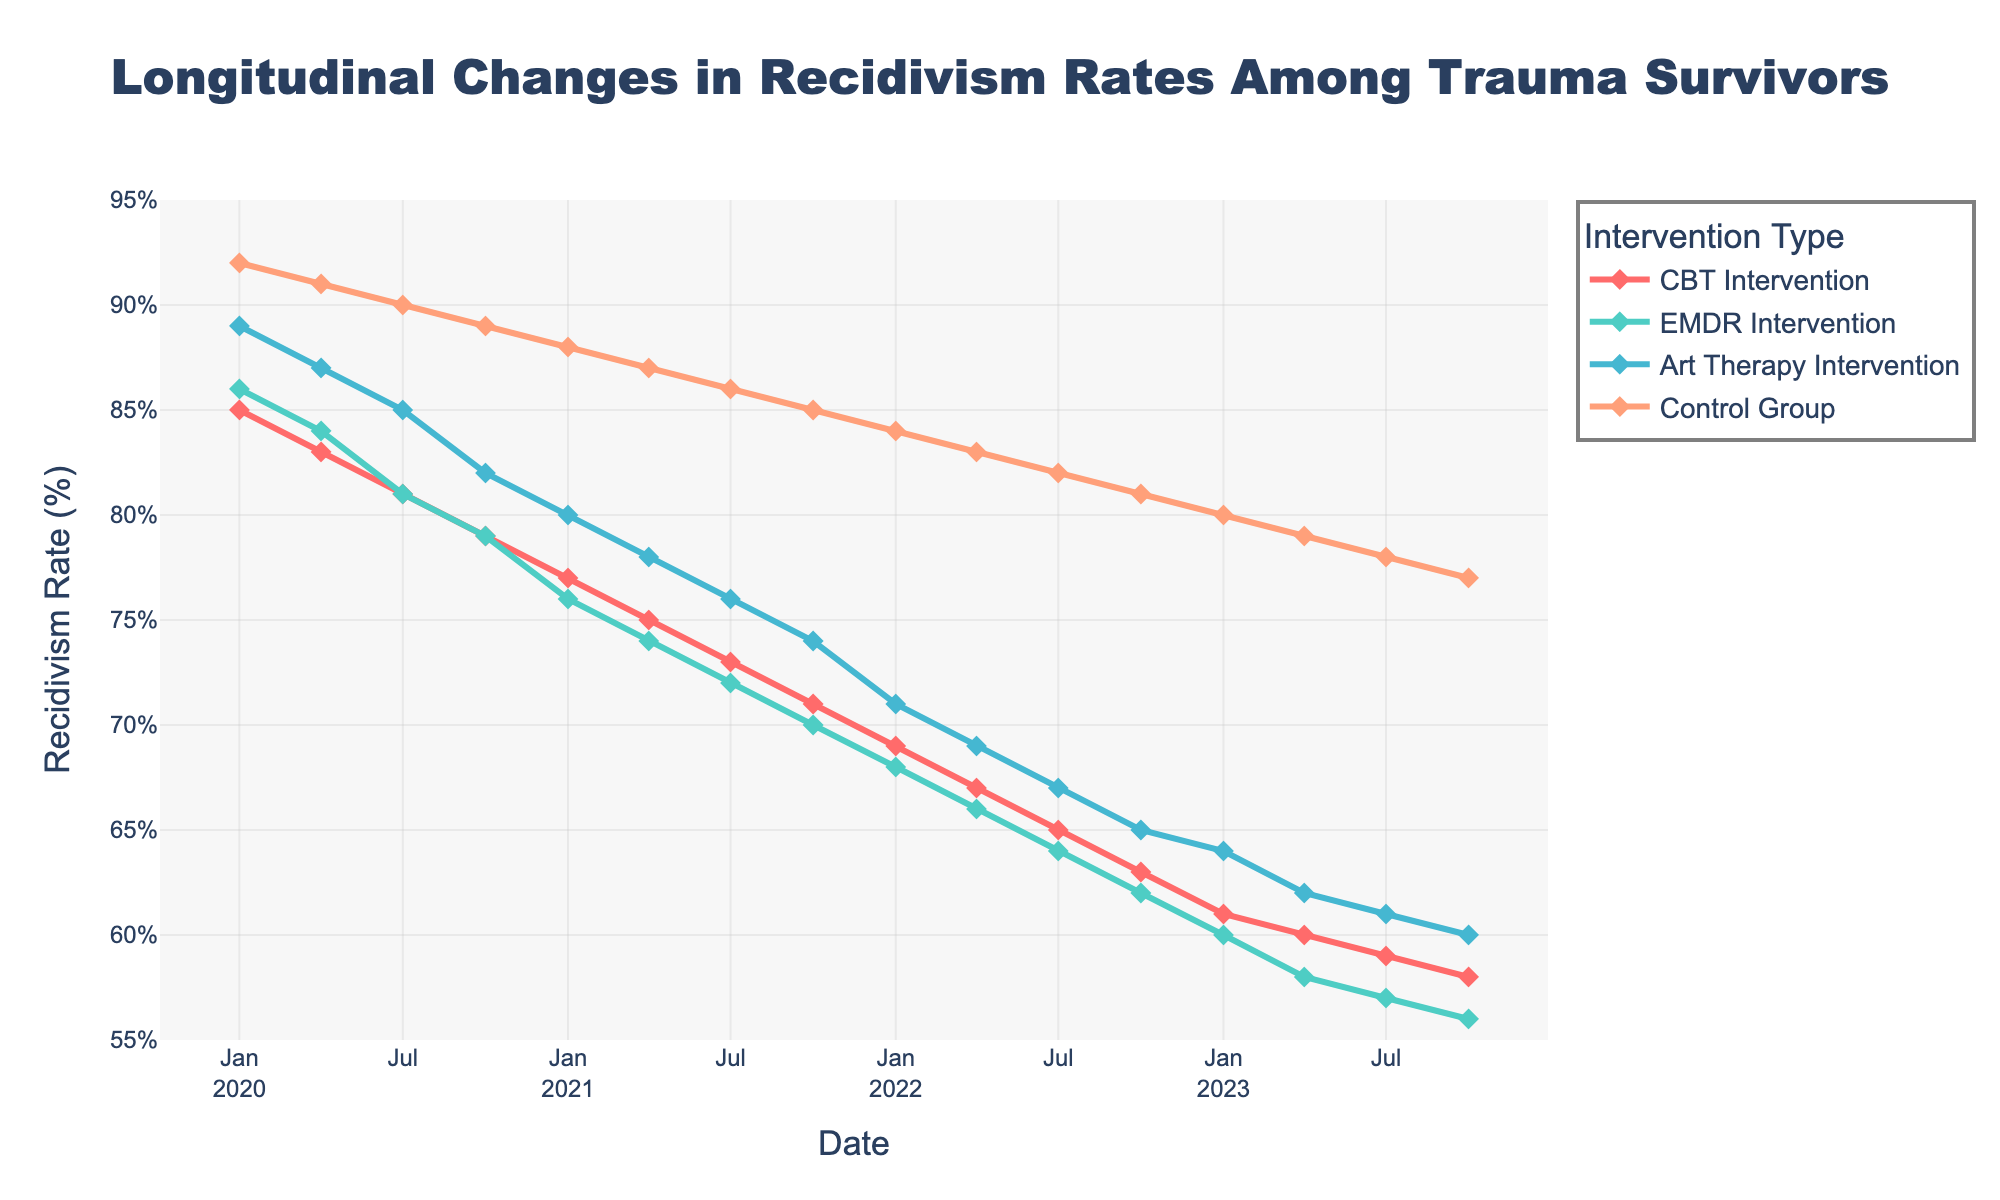What is the title of the figure? The title is typically displayed at the top of the figure. In this plot, the title is centered just above the graph area.
Answer: Longitudinal Changes in Recidivism Rates Among Trauma Survivors What does the y-axis represent? The label alongside the y-axis indicates what it measures.
Answer: Recidivism Rate (%) Which intervention shows the highest recidivism rate in January 2020? By looking at the data points for January 2020, we can compare the rates among different interventions. The Control Group has the highest rate at that time.
Answer: Control Group Between which two consecutive time points does the EMDR Intervention group experience the largest drop in recidivism rates? To determine this, we need to look at the changes in the y-values for the EMDR Intervention group and identify the largest decrease between consecutive dates. The largest drop occurred between January 2021 and April 2021.
Answer: January 2021 and April 2021 What's the overall trend for the CBT Intervention group from January 2020 to October 2023? Observing the curve for the CBT Intervention across the time period, we see a general decrease in the recidivism rate.
Answer: Downward trend How do the recidivism rates of the Art Therapy Intervention group compare to those of the Control Group in October 2023? Examine the y-values for both groups in October 2023. The Control Group has a higher rate than the Art Therapy Intervention group.
Answer: Art Therapy Intervention group has a lower rate What is the difference in recidivism rates between the CBT and EMDR interventions in April 2022? Subtract the EMDR rate from the CBT rate for April 2022. 67 - 66 = 1%.
Answer: 1% Which intervention group reaches a recidivism rate of 60% first, and when? By looking at each group's plot, identify the earliest date when any intervention group reaches a 60% rate. The EMDR Intervention group reaches 60% in April 2023.
Answer: EMDR Intervention in April 2023 What period shows the most considerable decrease for the Control group? By observing the Control group's curve, identify the segment with the steepest decline. The largest decrease occurs between July 2021 and October 2023.
Answer: July 2021 to October 2023 How many data points are plotted for each intervention group? Count the number of markers for any of the groups on the plot; as the data spans from January 2020 to October 2023 on a quarterly basis, each group has 16 data points.
Answer: 16 data points 